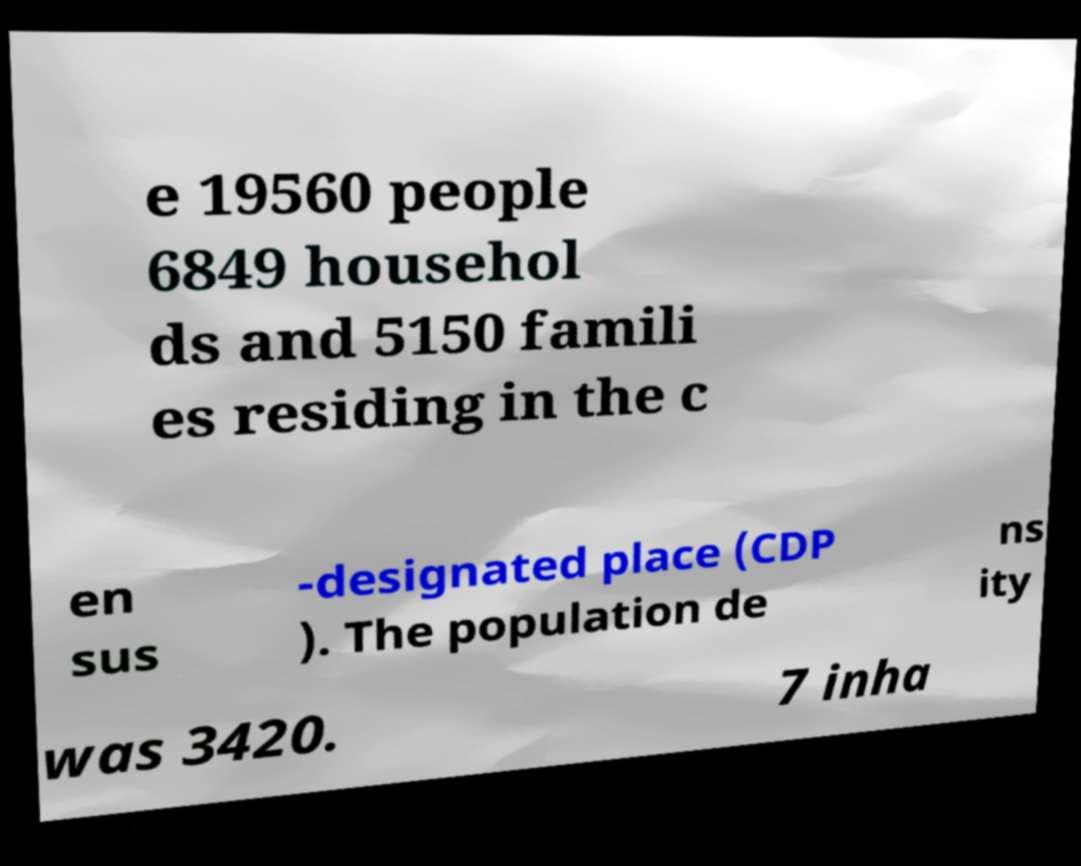I need the written content from this picture converted into text. Can you do that? e 19560 people 6849 househol ds and 5150 famili es residing in the c en sus -designated place (CDP ). The population de ns ity was 3420. 7 inha 